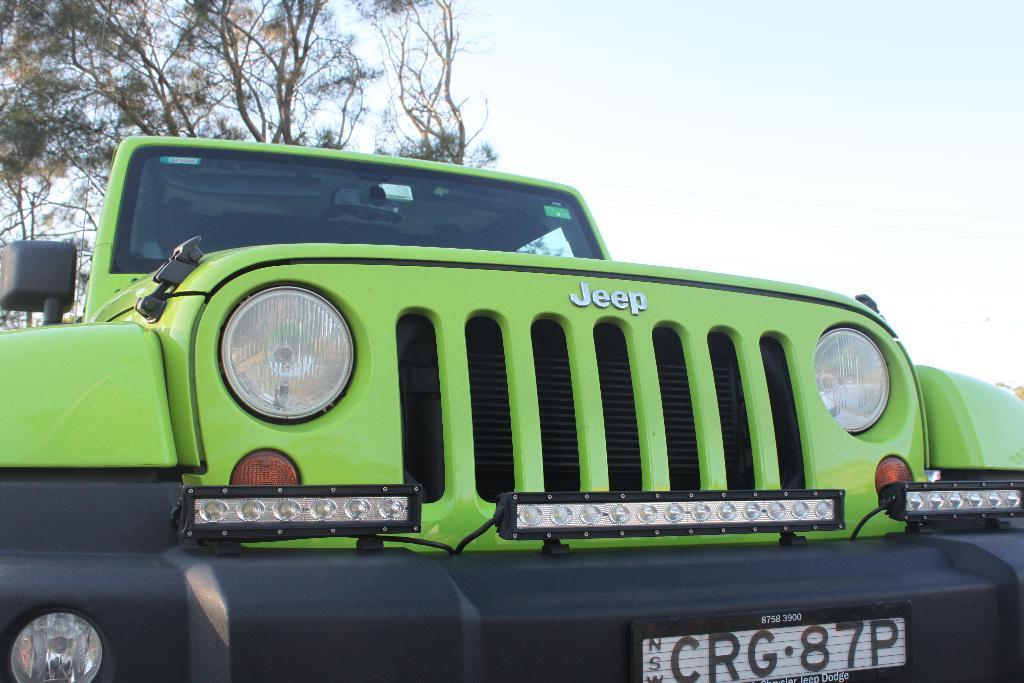Please provide a concise description of this image. This image consists of a jeep in green color. At the bottom, there is a bumper in black color. On the left, there is a tree. At the top, there is sky. 